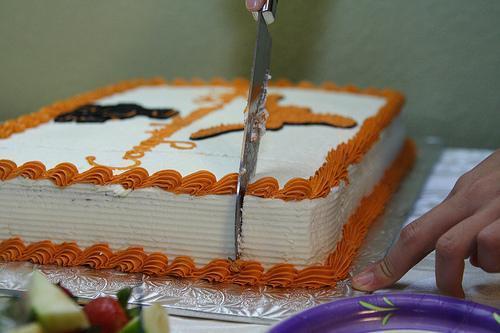How many people are there?
Give a very brief answer. 1. 